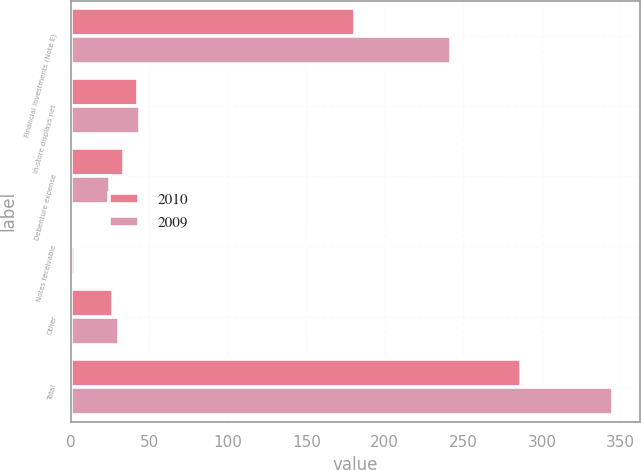Convert chart to OTSL. <chart><loc_0><loc_0><loc_500><loc_500><stacked_bar_chart><ecel><fcel>Financial investments (Note E)<fcel>In-store displays net<fcel>Debenture expense<fcel>Notes receivable<fcel>Other<fcel>Total<nl><fcel>2010<fcel>181<fcel>43<fcel>34<fcel>2<fcel>27<fcel>287<nl><fcel>2009<fcel>242<fcel>44<fcel>25<fcel>3<fcel>31<fcel>345<nl></chart> 